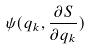<formula> <loc_0><loc_0><loc_500><loc_500>\psi ( q _ { k } , \frac { \partial S } { \partial q _ { k } } )</formula> 